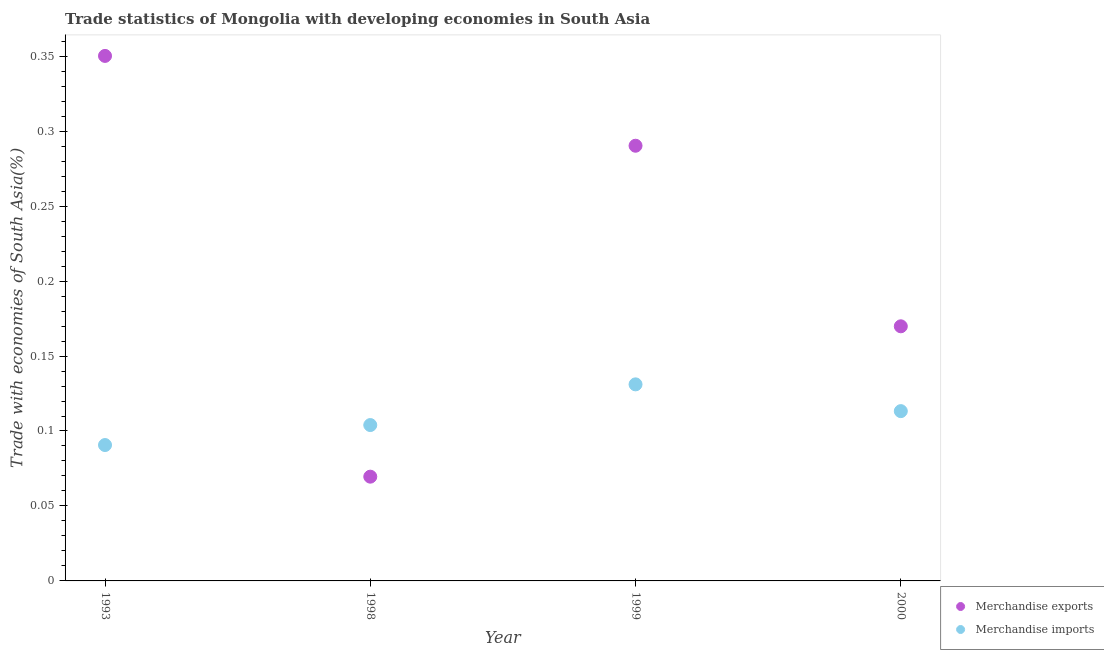What is the merchandise imports in 1993?
Your answer should be compact. 0.09. Across all years, what is the maximum merchandise imports?
Ensure brevity in your answer.  0.13. Across all years, what is the minimum merchandise exports?
Offer a very short reply. 0.07. In which year was the merchandise exports maximum?
Your answer should be compact. 1993. What is the total merchandise imports in the graph?
Give a very brief answer. 0.44. What is the difference between the merchandise imports in 1993 and that in 1998?
Give a very brief answer. -0.01. What is the difference between the merchandise exports in 1999 and the merchandise imports in 1993?
Your answer should be compact. 0.2. What is the average merchandise imports per year?
Your response must be concise. 0.11. In the year 1993, what is the difference between the merchandise imports and merchandise exports?
Make the answer very short. -0.26. What is the ratio of the merchandise exports in 1998 to that in 2000?
Ensure brevity in your answer.  0.41. Is the merchandise imports in 1993 less than that in 1998?
Your answer should be compact. Yes. Is the difference between the merchandise imports in 1993 and 1998 greater than the difference between the merchandise exports in 1993 and 1998?
Offer a very short reply. No. What is the difference between the highest and the second highest merchandise imports?
Provide a succinct answer. 0.02. What is the difference between the highest and the lowest merchandise imports?
Your answer should be very brief. 0.04. Is the sum of the merchandise exports in 1993 and 2000 greater than the maximum merchandise imports across all years?
Offer a terse response. Yes. Is the merchandise exports strictly less than the merchandise imports over the years?
Offer a terse response. No. What is the difference between two consecutive major ticks on the Y-axis?
Make the answer very short. 0.05. What is the title of the graph?
Offer a very short reply. Trade statistics of Mongolia with developing economies in South Asia. What is the label or title of the Y-axis?
Provide a short and direct response. Trade with economies of South Asia(%). What is the Trade with economies of South Asia(%) of Merchandise exports in 1993?
Provide a succinct answer. 0.35. What is the Trade with economies of South Asia(%) in Merchandise imports in 1993?
Your answer should be very brief. 0.09. What is the Trade with economies of South Asia(%) of Merchandise exports in 1998?
Provide a succinct answer. 0.07. What is the Trade with economies of South Asia(%) of Merchandise imports in 1998?
Give a very brief answer. 0.1. What is the Trade with economies of South Asia(%) in Merchandise exports in 1999?
Your answer should be very brief. 0.29. What is the Trade with economies of South Asia(%) of Merchandise imports in 1999?
Give a very brief answer. 0.13. What is the Trade with economies of South Asia(%) in Merchandise exports in 2000?
Your answer should be very brief. 0.17. What is the Trade with economies of South Asia(%) in Merchandise imports in 2000?
Offer a terse response. 0.11. Across all years, what is the maximum Trade with economies of South Asia(%) of Merchandise exports?
Provide a succinct answer. 0.35. Across all years, what is the maximum Trade with economies of South Asia(%) in Merchandise imports?
Your answer should be very brief. 0.13. Across all years, what is the minimum Trade with economies of South Asia(%) of Merchandise exports?
Make the answer very short. 0.07. Across all years, what is the minimum Trade with economies of South Asia(%) in Merchandise imports?
Give a very brief answer. 0.09. What is the total Trade with economies of South Asia(%) in Merchandise exports in the graph?
Give a very brief answer. 0.88. What is the total Trade with economies of South Asia(%) of Merchandise imports in the graph?
Make the answer very short. 0.44. What is the difference between the Trade with economies of South Asia(%) of Merchandise exports in 1993 and that in 1998?
Make the answer very short. 0.28. What is the difference between the Trade with economies of South Asia(%) in Merchandise imports in 1993 and that in 1998?
Provide a succinct answer. -0.01. What is the difference between the Trade with economies of South Asia(%) in Merchandise exports in 1993 and that in 1999?
Your answer should be very brief. 0.06. What is the difference between the Trade with economies of South Asia(%) of Merchandise imports in 1993 and that in 1999?
Make the answer very short. -0.04. What is the difference between the Trade with economies of South Asia(%) in Merchandise exports in 1993 and that in 2000?
Make the answer very short. 0.18. What is the difference between the Trade with economies of South Asia(%) in Merchandise imports in 1993 and that in 2000?
Ensure brevity in your answer.  -0.02. What is the difference between the Trade with economies of South Asia(%) in Merchandise exports in 1998 and that in 1999?
Keep it short and to the point. -0.22. What is the difference between the Trade with economies of South Asia(%) of Merchandise imports in 1998 and that in 1999?
Offer a very short reply. -0.03. What is the difference between the Trade with economies of South Asia(%) of Merchandise exports in 1998 and that in 2000?
Offer a very short reply. -0.1. What is the difference between the Trade with economies of South Asia(%) of Merchandise imports in 1998 and that in 2000?
Give a very brief answer. -0.01. What is the difference between the Trade with economies of South Asia(%) in Merchandise exports in 1999 and that in 2000?
Your answer should be very brief. 0.12. What is the difference between the Trade with economies of South Asia(%) in Merchandise imports in 1999 and that in 2000?
Your answer should be compact. 0.02. What is the difference between the Trade with economies of South Asia(%) of Merchandise exports in 1993 and the Trade with economies of South Asia(%) of Merchandise imports in 1998?
Provide a succinct answer. 0.25. What is the difference between the Trade with economies of South Asia(%) in Merchandise exports in 1993 and the Trade with economies of South Asia(%) in Merchandise imports in 1999?
Offer a terse response. 0.22. What is the difference between the Trade with economies of South Asia(%) in Merchandise exports in 1993 and the Trade with economies of South Asia(%) in Merchandise imports in 2000?
Offer a very short reply. 0.24. What is the difference between the Trade with economies of South Asia(%) of Merchandise exports in 1998 and the Trade with economies of South Asia(%) of Merchandise imports in 1999?
Give a very brief answer. -0.06. What is the difference between the Trade with economies of South Asia(%) of Merchandise exports in 1998 and the Trade with economies of South Asia(%) of Merchandise imports in 2000?
Offer a terse response. -0.04. What is the difference between the Trade with economies of South Asia(%) of Merchandise exports in 1999 and the Trade with economies of South Asia(%) of Merchandise imports in 2000?
Your answer should be compact. 0.18. What is the average Trade with economies of South Asia(%) in Merchandise exports per year?
Give a very brief answer. 0.22. What is the average Trade with economies of South Asia(%) in Merchandise imports per year?
Keep it short and to the point. 0.11. In the year 1993, what is the difference between the Trade with economies of South Asia(%) of Merchandise exports and Trade with economies of South Asia(%) of Merchandise imports?
Provide a succinct answer. 0.26. In the year 1998, what is the difference between the Trade with economies of South Asia(%) in Merchandise exports and Trade with economies of South Asia(%) in Merchandise imports?
Make the answer very short. -0.03. In the year 1999, what is the difference between the Trade with economies of South Asia(%) in Merchandise exports and Trade with economies of South Asia(%) in Merchandise imports?
Keep it short and to the point. 0.16. In the year 2000, what is the difference between the Trade with economies of South Asia(%) of Merchandise exports and Trade with economies of South Asia(%) of Merchandise imports?
Provide a succinct answer. 0.06. What is the ratio of the Trade with economies of South Asia(%) in Merchandise exports in 1993 to that in 1998?
Provide a succinct answer. 5.04. What is the ratio of the Trade with economies of South Asia(%) in Merchandise imports in 1993 to that in 1998?
Keep it short and to the point. 0.87. What is the ratio of the Trade with economies of South Asia(%) in Merchandise exports in 1993 to that in 1999?
Offer a terse response. 1.21. What is the ratio of the Trade with economies of South Asia(%) of Merchandise imports in 1993 to that in 1999?
Offer a terse response. 0.69. What is the ratio of the Trade with economies of South Asia(%) in Merchandise exports in 1993 to that in 2000?
Provide a short and direct response. 2.06. What is the ratio of the Trade with economies of South Asia(%) of Merchandise imports in 1993 to that in 2000?
Provide a succinct answer. 0.8. What is the ratio of the Trade with economies of South Asia(%) in Merchandise exports in 1998 to that in 1999?
Keep it short and to the point. 0.24. What is the ratio of the Trade with economies of South Asia(%) in Merchandise imports in 1998 to that in 1999?
Your answer should be compact. 0.79. What is the ratio of the Trade with economies of South Asia(%) of Merchandise exports in 1998 to that in 2000?
Keep it short and to the point. 0.41. What is the ratio of the Trade with economies of South Asia(%) of Merchandise imports in 1998 to that in 2000?
Provide a succinct answer. 0.92. What is the ratio of the Trade with economies of South Asia(%) of Merchandise exports in 1999 to that in 2000?
Keep it short and to the point. 1.71. What is the ratio of the Trade with economies of South Asia(%) in Merchandise imports in 1999 to that in 2000?
Your response must be concise. 1.16. What is the difference between the highest and the second highest Trade with economies of South Asia(%) of Merchandise exports?
Offer a very short reply. 0.06. What is the difference between the highest and the second highest Trade with economies of South Asia(%) of Merchandise imports?
Your answer should be very brief. 0.02. What is the difference between the highest and the lowest Trade with economies of South Asia(%) of Merchandise exports?
Provide a succinct answer. 0.28. What is the difference between the highest and the lowest Trade with economies of South Asia(%) of Merchandise imports?
Keep it short and to the point. 0.04. 